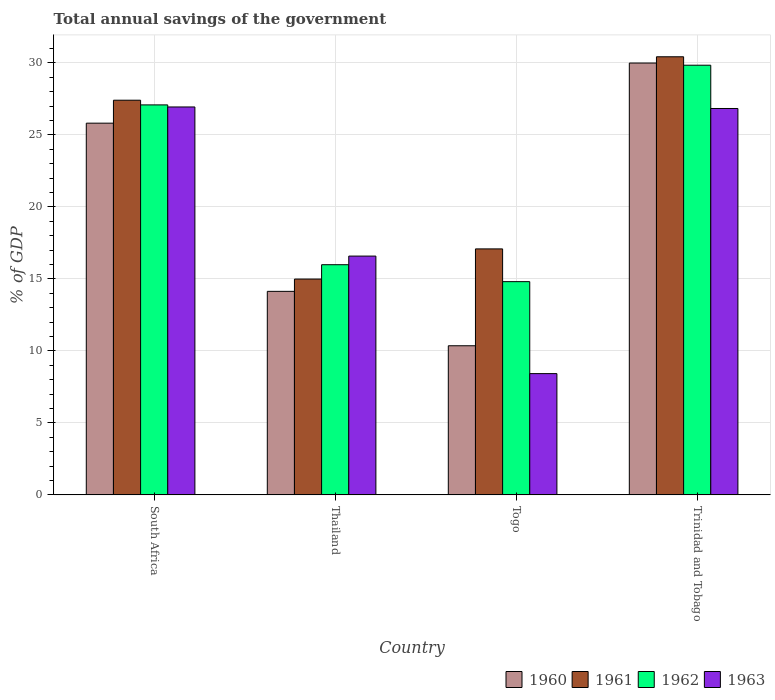How many groups of bars are there?
Give a very brief answer. 4. Are the number of bars per tick equal to the number of legend labels?
Make the answer very short. Yes. Are the number of bars on each tick of the X-axis equal?
Offer a very short reply. Yes. How many bars are there on the 1st tick from the right?
Offer a terse response. 4. What is the label of the 1st group of bars from the left?
Make the answer very short. South Africa. What is the total annual savings of the government in 1962 in South Africa?
Provide a short and direct response. 27.08. Across all countries, what is the maximum total annual savings of the government in 1961?
Ensure brevity in your answer.  30.42. Across all countries, what is the minimum total annual savings of the government in 1960?
Provide a succinct answer. 10.36. In which country was the total annual savings of the government in 1960 maximum?
Make the answer very short. Trinidad and Tobago. In which country was the total annual savings of the government in 1961 minimum?
Your answer should be very brief. Thailand. What is the total total annual savings of the government in 1963 in the graph?
Your answer should be very brief. 78.78. What is the difference between the total annual savings of the government in 1963 in South Africa and that in Thailand?
Provide a succinct answer. 10.36. What is the difference between the total annual savings of the government in 1962 in Thailand and the total annual savings of the government in 1961 in Trinidad and Tobago?
Your answer should be compact. -14.44. What is the average total annual savings of the government in 1961 per country?
Ensure brevity in your answer.  22.48. What is the difference between the total annual savings of the government of/in 1961 and total annual savings of the government of/in 1963 in Trinidad and Tobago?
Your answer should be compact. 3.59. In how many countries, is the total annual savings of the government in 1960 greater than 16 %?
Offer a terse response. 2. What is the ratio of the total annual savings of the government in 1961 in Togo to that in Trinidad and Tobago?
Provide a succinct answer. 0.56. Is the total annual savings of the government in 1962 in Thailand less than that in Trinidad and Tobago?
Provide a short and direct response. Yes. Is the difference between the total annual savings of the government in 1961 in South Africa and Thailand greater than the difference between the total annual savings of the government in 1963 in South Africa and Thailand?
Offer a very short reply. Yes. What is the difference between the highest and the second highest total annual savings of the government in 1961?
Provide a succinct answer. -10.33. What is the difference between the highest and the lowest total annual savings of the government in 1961?
Make the answer very short. 15.44. Is it the case that in every country, the sum of the total annual savings of the government in 1962 and total annual savings of the government in 1961 is greater than the sum of total annual savings of the government in 1960 and total annual savings of the government in 1963?
Ensure brevity in your answer.  No. Is it the case that in every country, the sum of the total annual savings of the government in 1961 and total annual savings of the government in 1963 is greater than the total annual savings of the government in 1960?
Your response must be concise. Yes. How many bars are there?
Your answer should be compact. 16. Are all the bars in the graph horizontal?
Ensure brevity in your answer.  No. How many countries are there in the graph?
Provide a succinct answer. 4. What is the difference between two consecutive major ticks on the Y-axis?
Your answer should be compact. 5. Does the graph contain grids?
Ensure brevity in your answer.  Yes. Where does the legend appear in the graph?
Make the answer very short. Bottom right. How many legend labels are there?
Offer a very short reply. 4. How are the legend labels stacked?
Keep it short and to the point. Horizontal. What is the title of the graph?
Give a very brief answer. Total annual savings of the government. Does "2008" appear as one of the legend labels in the graph?
Your response must be concise. No. What is the label or title of the X-axis?
Ensure brevity in your answer.  Country. What is the label or title of the Y-axis?
Provide a succinct answer. % of GDP. What is the % of GDP of 1960 in South Africa?
Provide a short and direct response. 25.81. What is the % of GDP of 1961 in South Africa?
Your answer should be compact. 27.41. What is the % of GDP of 1962 in South Africa?
Keep it short and to the point. 27.08. What is the % of GDP of 1963 in South Africa?
Give a very brief answer. 26.94. What is the % of GDP of 1960 in Thailand?
Your answer should be very brief. 14.13. What is the % of GDP in 1961 in Thailand?
Keep it short and to the point. 14.99. What is the % of GDP of 1962 in Thailand?
Offer a terse response. 15.99. What is the % of GDP in 1963 in Thailand?
Provide a short and direct response. 16.58. What is the % of GDP in 1960 in Togo?
Offer a terse response. 10.36. What is the % of GDP of 1961 in Togo?
Offer a very short reply. 17.08. What is the % of GDP in 1962 in Togo?
Keep it short and to the point. 14.81. What is the % of GDP of 1963 in Togo?
Your response must be concise. 8.42. What is the % of GDP in 1960 in Trinidad and Tobago?
Your answer should be very brief. 29.99. What is the % of GDP in 1961 in Trinidad and Tobago?
Offer a terse response. 30.42. What is the % of GDP of 1962 in Trinidad and Tobago?
Your answer should be very brief. 29.84. What is the % of GDP of 1963 in Trinidad and Tobago?
Keep it short and to the point. 26.83. Across all countries, what is the maximum % of GDP in 1960?
Provide a succinct answer. 29.99. Across all countries, what is the maximum % of GDP in 1961?
Your response must be concise. 30.42. Across all countries, what is the maximum % of GDP in 1962?
Provide a short and direct response. 29.84. Across all countries, what is the maximum % of GDP in 1963?
Offer a very short reply. 26.94. Across all countries, what is the minimum % of GDP of 1960?
Give a very brief answer. 10.36. Across all countries, what is the minimum % of GDP in 1961?
Your response must be concise. 14.99. Across all countries, what is the minimum % of GDP in 1962?
Keep it short and to the point. 14.81. Across all countries, what is the minimum % of GDP in 1963?
Provide a short and direct response. 8.42. What is the total % of GDP of 1960 in the graph?
Your response must be concise. 80.3. What is the total % of GDP of 1961 in the graph?
Offer a terse response. 89.91. What is the total % of GDP of 1962 in the graph?
Keep it short and to the point. 87.72. What is the total % of GDP in 1963 in the graph?
Give a very brief answer. 78.78. What is the difference between the % of GDP of 1960 in South Africa and that in Thailand?
Ensure brevity in your answer.  11.68. What is the difference between the % of GDP of 1961 in South Africa and that in Thailand?
Provide a short and direct response. 12.42. What is the difference between the % of GDP in 1962 in South Africa and that in Thailand?
Offer a very short reply. 11.1. What is the difference between the % of GDP in 1963 in South Africa and that in Thailand?
Keep it short and to the point. 10.36. What is the difference between the % of GDP of 1960 in South Africa and that in Togo?
Your answer should be compact. 15.46. What is the difference between the % of GDP in 1961 in South Africa and that in Togo?
Ensure brevity in your answer.  10.33. What is the difference between the % of GDP of 1962 in South Africa and that in Togo?
Provide a succinct answer. 12.28. What is the difference between the % of GDP in 1963 in South Africa and that in Togo?
Provide a short and direct response. 18.52. What is the difference between the % of GDP in 1960 in South Africa and that in Trinidad and Tobago?
Make the answer very short. -4.18. What is the difference between the % of GDP in 1961 in South Africa and that in Trinidad and Tobago?
Provide a succinct answer. -3.02. What is the difference between the % of GDP of 1962 in South Africa and that in Trinidad and Tobago?
Offer a very short reply. -2.76. What is the difference between the % of GDP in 1963 in South Africa and that in Trinidad and Tobago?
Your response must be concise. 0.11. What is the difference between the % of GDP in 1960 in Thailand and that in Togo?
Your answer should be very brief. 3.78. What is the difference between the % of GDP in 1961 in Thailand and that in Togo?
Give a very brief answer. -2.09. What is the difference between the % of GDP of 1962 in Thailand and that in Togo?
Give a very brief answer. 1.18. What is the difference between the % of GDP in 1963 in Thailand and that in Togo?
Make the answer very short. 8.16. What is the difference between the % of GDP in 1960 in Thailand and that in Trinidad and Tobago?
Your answer should be very brief. -15.86. What is the difference between the % of GDP of 1961 in Thailand and that in Trinidad and Tobago?
Your response must be concise. -15.44. What is the difference between the % of GDP of 1962 in Thailand and that in Trinidad and Tobago?
Offer a terse response. -13.85. What is the difference between the % of GDP of 1963 in Thailand and that in Trinidad and Tobago?
Provide a short and direct response. -10.25. What is the difference between the % of GDP in 1960 in Togo and that in Trinidad and Tobago?
Your answer should be compact. -19.63. What is the difference between the % of GDP in 1961 in Togo and that in Trinidad and Tobago?
Offer a terse response. -13.34. What is the difference between the % of GDP in 1962 in Togo and that in Trinidad and Tobago?
Give a very brief answer. -15.03. What is the difference between the % of GDP in 1963 in Togo and that in Trinidad and Tobago?
Your response must be concise. -18.41. What is the difference between the % of GDP of 1960 in South Africa and the % of GDP of 1961 in Thailand?
Provide a succinct answer. 10.83. What is the difference between the % of GDP in 1960 in South Africa and the % of GDP in 1962 in Thailand?
Your answer should be compact. 9.83. What is the difference between the % of GDP of 1960 in South Africa and the % of GDP of 1963 in Thailand?
Offer a terse response. 9.23. What is the difference between the % of GDP of 1961 in South Africa and the % of GDP of 1962 in Thailand?
Keep it short and to the point. 11.42. What is the difference between the % of GDP of 1961 in South Africa and the % of GDP of 1963 in Thailand?
Provide a short and direct response. 10.82. What is the difference between the % of GDP in 1962 in South Africa and the % of GDP in 1963 in Thailand?
Offer a very short reply. 10.5. What is the difference between the % of GDP of 1960 in South Africa and the % of GDP of 1961 in Togo?
Provide a short and direct response. 8.73. What is the difference between the % of GDP of 1960 in South Africa and the % of GDP of 1962 in Togo?
Your answer should be compact. 11.01. What is the difference between the % of GDP in 1960 in South Africa and the % of GDP in 1963 in Togo?
Provide a succinct answer. 17.39. What is the difference between the % of GDP of 1961 in South Africa and the % of GDP of 1962 in Togo?
Your answer should be compact. 12.6. What is the difference between the % of GDP in 1961 in South Africa and the % of GDP in 1963 in Togo?
Ensure brevity in your answer.  18.99. What is the difference between the % of GDP in 1962 in South Africa and the % of GDP in 1963 in Togo?
Ensure brevity in your answer.  18.66. What is the difference between the % of GDP of 1960 in South Africa and the % of GDP of 1961 in Trinidad and Tobago?
Provide a succinct answer. -4.61. What is the difference between the % of GDP of 1960 in South Africa and the % of GDP of 1962 in Trinidad and Tobago?
Provide a succinct answer. -4.02. What is the difference between the % of GDP in 1960 in South Africa and the % of GDP in 1963 in Trinidad and Tobago?
Your answer should be compact. -1.02. What is the difference between the % of GDP in 1961 in South Africa and the % of GDP in 1962 in Trinidad and Tobago?
Provide a succinct answer. -2.43. What is the difference between the % of GDP in 1961 in South Africa and the % of GDP in 1963 in Trinidad and Tobago?
Provide a short and direct response. 0.57. What is the difference between the % of GDP of 1962 in South Africa and the % of GDP of 1963 in Trinidad and Tobago?
Make the answer very short. 0.25. What is the difference between the % of GDP of 1960 in Thailand and the % of GDP of 1961 in Togo?
Your answer should be compact. -2.95. What is the difference between the % of GDP in 1960 in Thailand and the % of GDP in 1962 in Togo?
Ensure brevity in your answer.  -0.67. What is the difference between the % of GDP in 1960 in Thailand and the % of GDP in 1963 in Togo?
Offer a very short reply. 5.71. What is the difference between the % of GDP of 1961 in Thailand and the % of GDP of 1962 in Togo?
Provide a succinct answer. 0.18. What is the difference between the % of GDP in 1961 in Thailand and the % of GDP in 1963 in Togo?
Provide a succinct answer. 6.57. What is the difference between the % of GDP in 1962 in Thailand and the % of GDP in 1963 in Togo?
Keep it short and to the point. 7.56. What is the difference between the % of GDP in 1960 in Thailand and the % of GDP in 1961 in Trinidad and Tobago?
Keep it short and to the point. -16.29. What is the difference between the % of GDP of 1960 in Thailand and the % of GDP of 1962 in Trinidad and Tobago?
Your answer should be very brief. -15.7. What is the difference between the % of GDP of 1960 in Thailand and the % of GDP of 1963 in Trinidad and Tobago?
Offer a very short reply. -12.7. What is the difference between the % of GDP in 1961 in Thailand and the % of GDP in 1962 in Trinidad and Tobago?
Give a very brief answer. -14.85. What is the difference between the % of GDP of 1961 in Thailand and the % of GDP of 1963 in Trinidad and Tobago?
Your answer should be very brief. -11.85. What is the difference between the % of GDP in 1962 in Thailand and the % of GDP in 1963 in Trinidad and Tobago?
Your response must be concise. -10.85. What is the difference between the % of GDP in 1960 in Togo and the % of GDP in 1961 in Trinidad and Tobago?
Offer a very short reply. -20.07. What is the difference between the % of GDP in 1960 in Togo and the % of GDP in 1962 in Trinidad and Tobago?
Your response must be concise. -19.48. What is the difference between the % of GDP of 1960 in Togo and the % of GDP of 1963 in Trinidad and Tobago?
Offer a very short reply. -16.48. What is the difference between the % of GDP of 1961 in Togo and the % of GDP of 1962 in Trinidad and Tobago?
Ensure brevity in your answer.  -12.76. What is the difference between the % of GDP in 1961 in Togo and the % of GDP in 1963 in Trinidad and Tobago?
Give a very brief answer. -9.75. What is the difference between the % of GDP in 1962 in Togo and the % of GDP in 1963 in Trinidad and Tobago?
Your response must be concise. -12.03. What is the average % of GDP in 1960 per country?
Keep it short and to the point. 20.07. What is the average % of GDP in 1961 per country?
Your answer should be very brief. 22.48. What is the average % of GDP in 1962 per country?
Provide a succinct answer. 21.93. What is the average % of GDP in 1963 per country?
Your answer should be compact. 19.7. What is the difference between the % of GDP of 1960 and % of GDP of 1961 in South Africa?
Provide a succinct answer. -1.59. What is the difference between the % of GDP in 1960 and % of GDP in 1962 in South Africa?
Provide a succinct answer. -1.27. What is the difference between the % of GDP in 1960 and % of GDP in 1963 in South Africa?
Provide a short and direct response. -1.13. What is the difference between the % of GDP of 1961 and % of GDP of 1962 in South Africa?
Ensure brevity in your answer.  0.33. What is the difference between the % of GDP of 1961 and % of GDP of 1963 in South Africa?
Offer a very short reply. 0.47. What is the difference between the % of GDP in 1962 and % of GDP in 1963 in South Africa?
Provide a succinct answer. 0.14. What is the difference between the % of GDP of 1960 and % of GDP of 1961 in Thailand?
Your answer should be compact. -0.85. What is the difference between the % of GDP in 1960 and % of GDP in 1962 in Thailand?
Ensure brevity in your answer.  -1.85. What is the difference between the % of GDP in 1960 and % of GDP in 1963 in Thailand?
Provide a succinct answer. -2.45. What is the difference between the % of GDP of 1961 and % of GDP of 1962 in Thailand?
Offer a terse response. -1. What is the difference between the % of GDP in 1961 and % of GDP in 1963 in Thailand?
Offer a terse response. -1.59. What is the difference between the % of GDP of 1962 and % of GDP of 1963 in Thailand?
Keep it short and to the point. -0.6. What is the difference between the % of GDP in 1960 and % of GDP in 1961 in Togo?
Your answer should be very brief. -6.73. What is the difference between the % of GDP in 1960 and % of GDP in 1962 in Togo?
Provide a succinct answer. -4.45. What is the difference between the % of GDP in 1960 and % of GDP in 1963 in Togo?
Make the answer very short. 1.93. What is the difference between the % of GDP in 1961 and % of GDP in 1962 in Togo?
Make the answer very short. 2.27. What is the difference between the % of GDP in 1961 and % of GDP in 1963 in Togo?
Give a very brief answer. 8.66. What is the difference between the % of GDP in 1962 and % of GDP in 1963 in Togo?
Ensure brevity in your answer.  6.39. What is the difference between the % of GDP of 1960 and % of GDP of 1961 in Trinidad and Tobago?
Keep it short and to the point. -0.43. What is the difference between the % of GDP of 1960 and % of GDP of 1962 in Trinidad and Tobago?
Provide a succinct answer. 0.15. What is the difference between the % of GDP of 1960 and % of GDP of 1963 in Trinidad and Tobago?
Make the answer very short. 3.16. What is the difference between the % of GDP in 1961 and % of GDP in 1962 in Trinidad and Tobago?
Your answer should be very brief. 0.59. What is the difference between the % of GDP in 1961 and % of GDP in 1963 in Trinidad and Tobago?
Provide a succinct answer. 3.59. What is the difference between the % of GDP of 1962 and % of GDP of 1963 in Trinidad and Tobago?
Offer a terse response. 3. What is the ratio of the % of GDP of 1960 in South Africa to that in Thailand?
Offer a very short reply. 1.83. What is the ratio of the % of GDP in 1961 in South Africa to that in Thailand?
Provide a short and direct response. 1.83. What is the ratio of the % of GDP of 1962 in South Africa to that in Thailand?
Offer a very short reply. 1.69. What is the ratio of the % of GDP in 1963 in South Africa to that in Thailand?
Make the answer very short. 1.62. What is the ratio of the % of GDP in 1960 in South Africa to that in Togo?
Your answer should be very brief. 2.49. What is the ratio of the % of GDP in 1961 in South Africa to that in Togo?
Offer a terse response. 1.6. What is the ratio of the % of GDP in 1962 in South Africa to that in Togo?
Keep it short and to the point. 1.83. What is the ratio of the % of GDP of 1963 in South Africa to that in Togo?
Provide a succinct answer. 3.2. What is the ratio of the % of GDP of 1960 in South Africa to that in Trinidad and Tobago?
Offer a very short reply. 0.86. What is the ratio of the % of GDP of 1961 in South Africa to that in Trinidad and Tobago?
Offer a terse response. 0.9. What is the ratio of the % of GDP of 1962 in South Africa to that in Trinidad and Tobago?
Your answer should be compact. 0.91. What is the ratio of the % of GDP of 1963 in South Africa to that in Trinidad and Tobago?
Make the answer very short. 1. What is the ratio of the % of GDP in 1960 in Thailand to that in Togo?
Offer a very short reply. 1.36. What is the ratio of the % of GDP in 1961 in Thailand to that in Togo?
Your answer should be compact. 0.88. What is the ratio of the % of GDP in 1962 in Thailand to that in Togo?
Make the answer very short. 1.08. What is the ratio of the % of GDP of 1963 in Thailand to that in Togo?
Offer a terse response. 1.97. What is the ratio of the % of GDP in 1960 in Thailand to that in Trinidad and Tobago?
Make the answer very short. 0.47. What is the ratio of the % of GDP of 1961 in Thailand to that in Trinidad and Tobago?
Provide a short and direct response. 0.49. What is the ratio of the % of GDP in 1962 in Thailand to that in Trinidad and Tobago?
Ensure brevity in your answer.  0.54. What is the ratio of the % of GDP of 1963 in Thailand to that in Trinidad and Tobago?
Your answer should be very brief. 0.62. What is the ratio of the % of GDP of 1960 in Togo to that in Trinidad and Tobago?
Offer a terse response. 0.35. What is the ratio of the % of GDP in 1961 in Togo to that in Trinidad and Tobago?
Offer a terse response. 0.56. What is the ratio of the % of GDP in 1962 in Togo to that in Trinidad and Tobago?
Your answer should be compact. 0.5. What is the ratio of the % of GDP in 1963 in Togo to that in Trinidad and Tobago?
Your response must be concise. 0.31. What is the difference between the highest and the second highest % of GDP of 1960?
Offer a terse response. 4.18. What is the difference between the highest and the second highest % of GDP in 1961?
Provide a succinct answer. 3.02. What is the difference between the highest and the second highest % of GDP of 1962?
Give a very brief answer. 2.76. What is the difference between the highest and the second highest % of GDP in 1963?
Ensure brevity in your answer.  0.11. What is the difference between the highest and the lowest % of GDP of 1960?
Give a very brief answer. 19.63. What is the difference between the highest and the lowest % of GDP in 1961?
Provide a succinct answer. 15.44. What is the difference between the highest and the lowest % of GDP of 1962?
Your answer should be compact. 15.03. What is the difference between the highest and the lowest % of GDP of 1963?
Offer a very short reply. 18.52. 